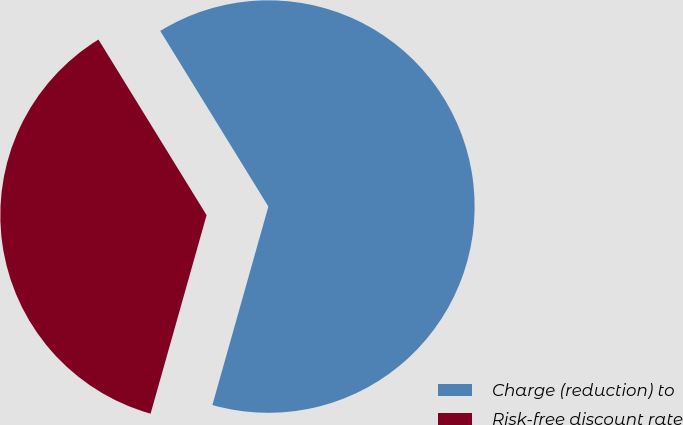Convert chart. <chart><loc_0><loc_0><loc_500><loc_500><pie_chart><fcel>Charge (reduction) to<fcel>Risk-free discount rate<nl><fcel>63.16%<fcel>36.84%<nl></chart> 